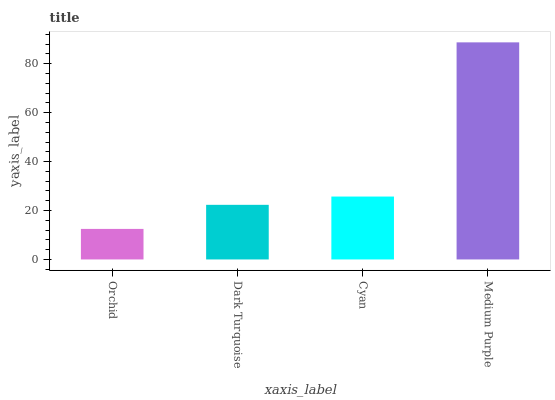Is Dark Turquoise the minimum?
Answer yes or no. No. Is Dark Turquoise the maximum?
Answer yes or no. No. Is Dark Turquoise greater than Orchid?
Answer yes or no. Yes. Is Orchid less than Dark Turquoise?
Answer yes or no. Yes. Is Orchid greater than Dark Turquoise?
Answer yes or no. No. Is Dark Turquoise less than Orchid?
Answer yes or no. No. Is Cyan the high median?
Answer yes or no. Yes. Is Dark Turquoise the low median?
Answer yes or no. Yes. Is Orchid the high median?
Answer yes or no. No. Is Medium Purple the low median?
Answer yes or no. No. 